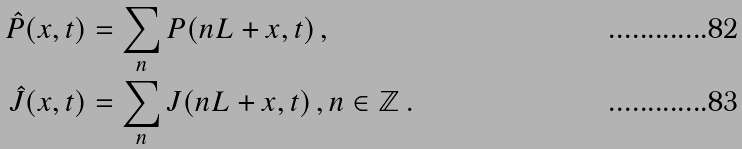<formula> <loc_0><loc_0><loc_500><loc_500>\hat { P } ( x , t ) & = \sum _ { n } P ( n L + x , t ) \, , \\ \hat { J } ( x , t ) & = \sum _ { n } J ( n L + x , t ) \, , n \in \mathbb { Z } \, .</formula> 